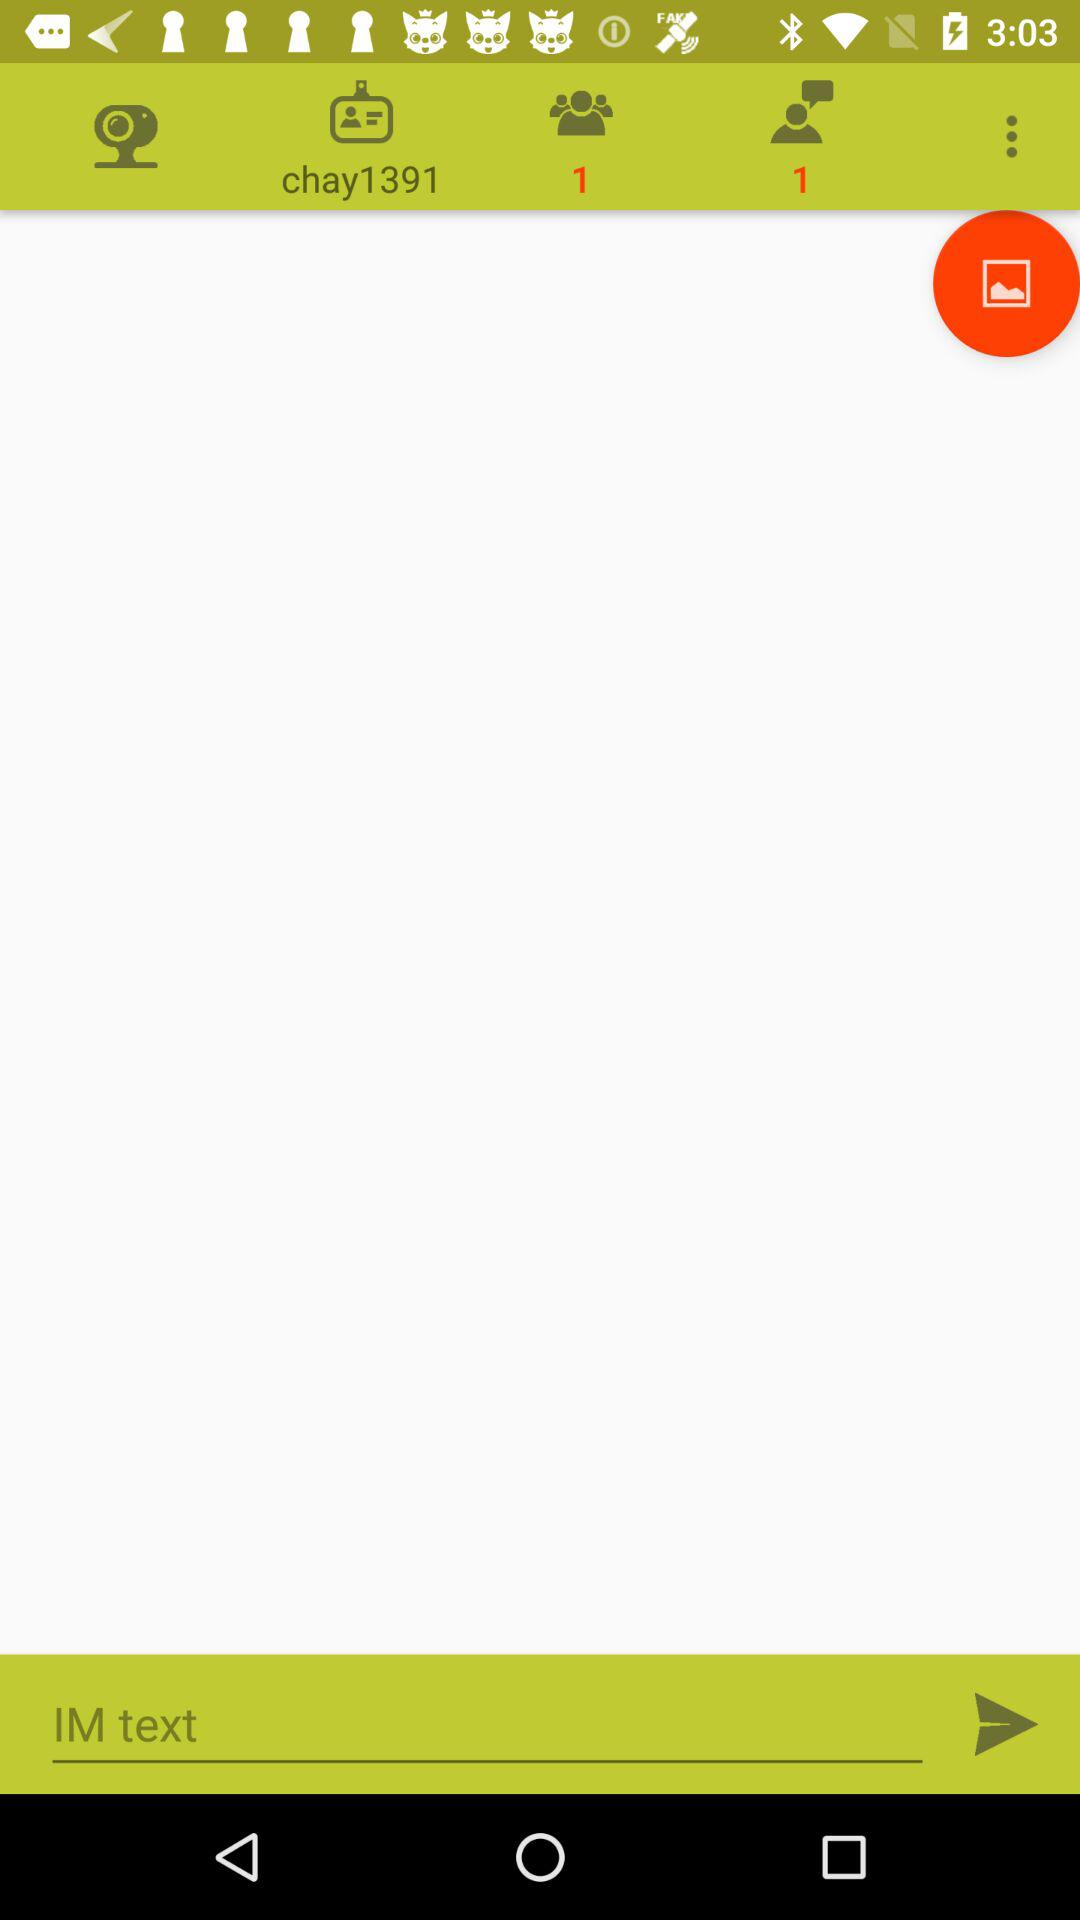How many messages are there? There is 1 message. 